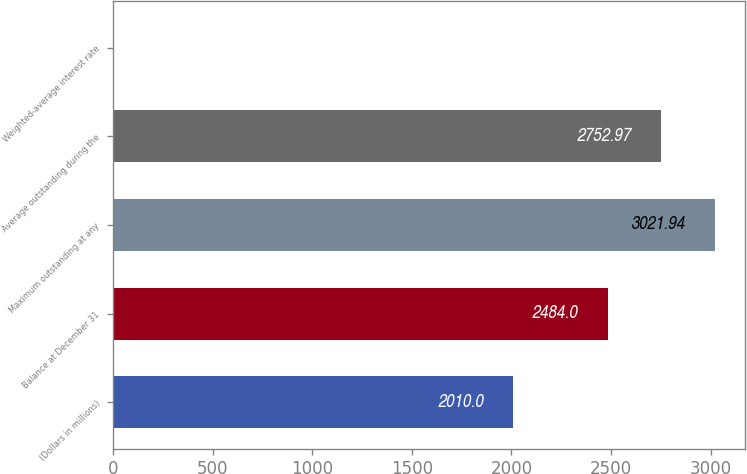Convert chart. <chart><loc_0><loc_0><loc_500><loc_500><bar_chart><fcel>(Dollars in millions)<fcel>Balance at December 31<fcel>Maximum outstanding at any<fcel>Average outstanding during the<fcel>Weighted-average interest rate<nl><fcel>2010<fcel>2484<fcel>3021.94<fcel>2752.97<fcel>0.33<nl></chart> 